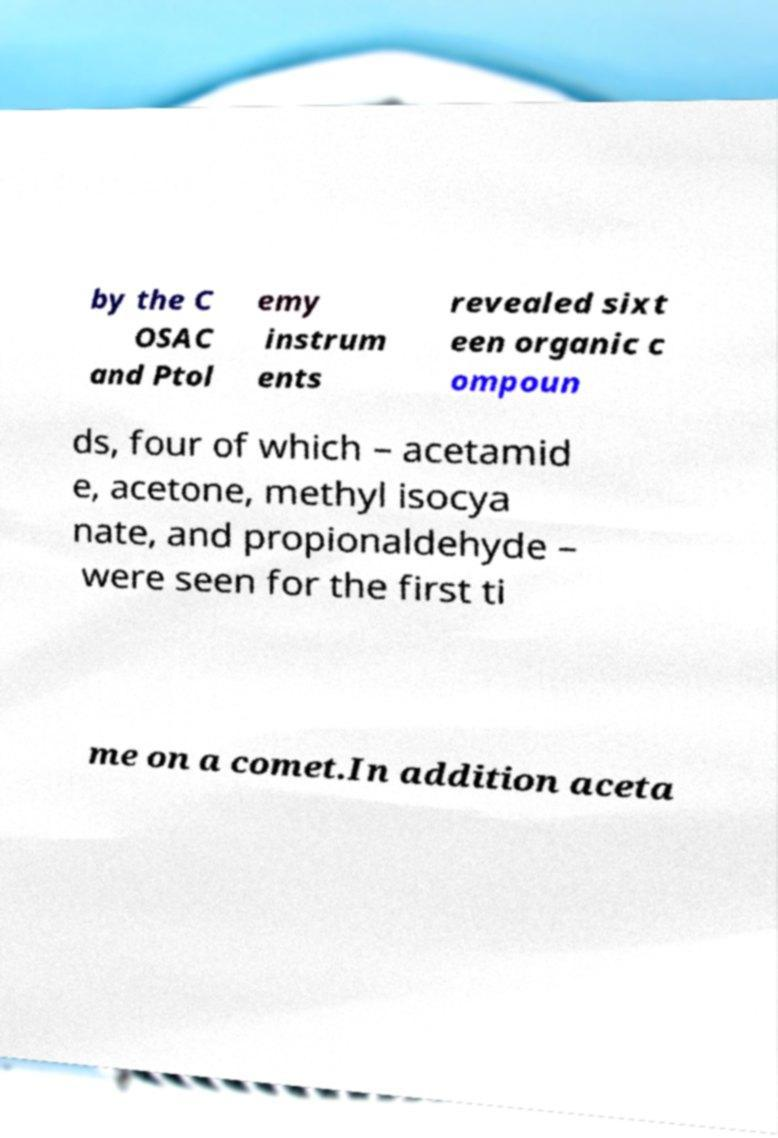Can you read and provide the text displayed in the image?This photo seems to have some interesting text. Can you extract and type it out for me? by the C OSAC and Ptol emy instrum ents revealed sixt een organic c ompoun ds, four of which – acetamid e, acetone, methyl isocya nate, and propionaldehyde – were seen for the first ti me on a comet.In addition aceta 